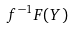Convert formula to latex. <formula><loc_0><loc_0><loc_500><loc_500>f ^ { - 1 } F ( Y )</formula> 